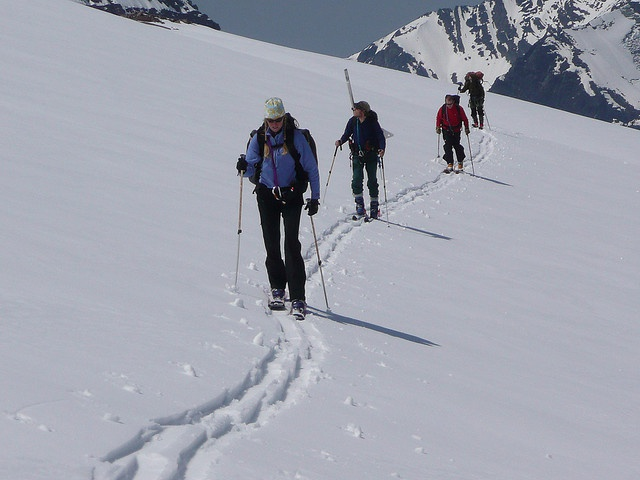Describe the objects in this image and their specific colors. I can see people in darkgray, black, navy, gray, and darkblue tones, people in darkgray, black, gray, and navy tones, people in darkgray, black, maroon, and gray tones, people in darkgray, black, lightgray, and gray tones, and backpack in darkgray, black, navy, gray, and purple tones in this image. 